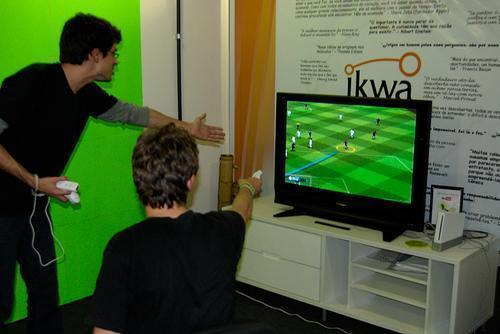What do these young people pretend to do?
Answer the question by selecting the correct answer among the 4 following choices.
Options: Strum guitar, play soccer, play tennis, bike. Play soccer. 